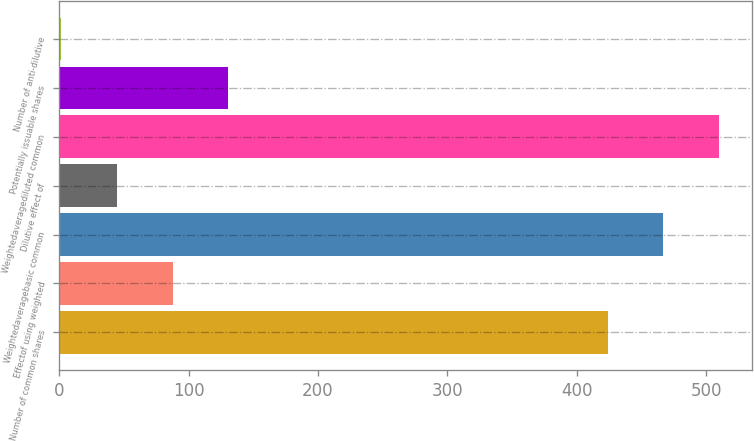Convert chart. <chart><loc_0><loc_0><loc_500><loc_500><bar_chart><fcel>Number of common shares<fcel>Effectof using weighted<fcel>Weightedaveragebasic common<fcel>Dilutive effect of<fcel>Weightedaveragediluted common<fcel>Potentially issuable shares<fcel>Number of anti-dilutive<nl><fcel>424<fcel>87.64<fcel>467.07<fcel>44.57<fcel>510.14<fcel>130.71<fcel>1.5<nl></chart> 